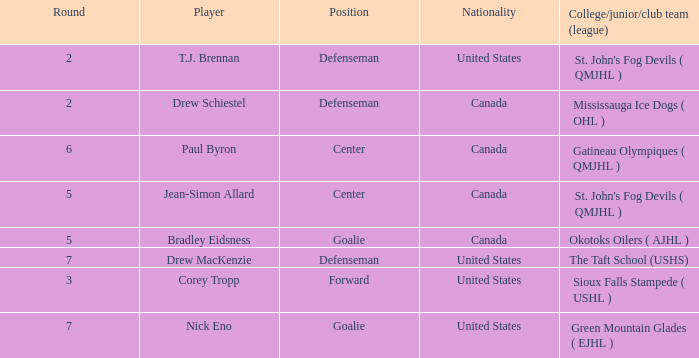What is the nationality of the goalie in Round 7? United States. 